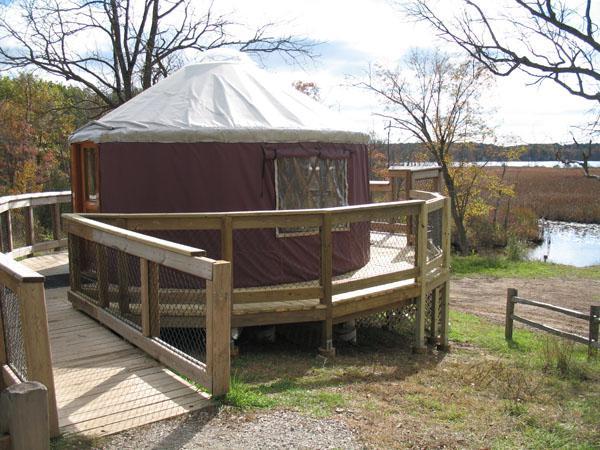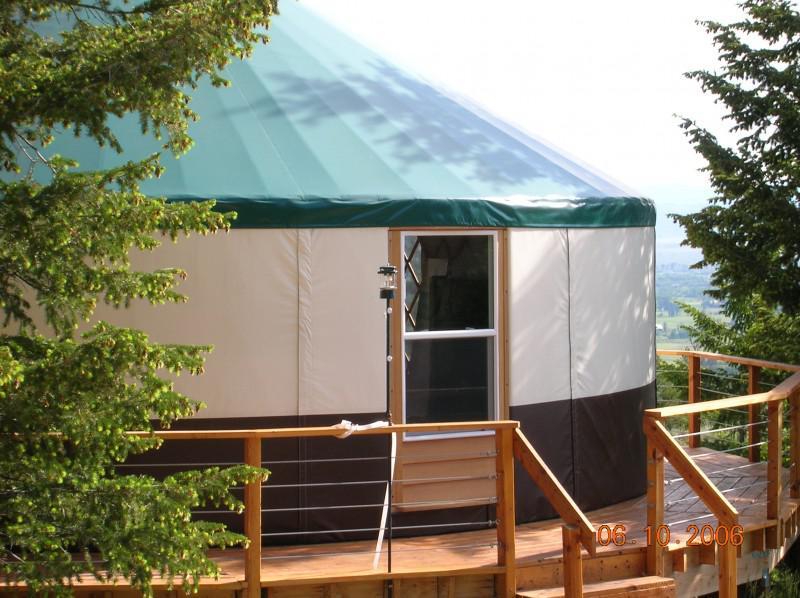The first image is the image on the left, the second image is the image on the right. Considering the images on both sides, is "Each image shows the front door of a single-story yurt with a roof that contrasts the walls, and a wooden decking entrance with railings." valid? Answer yes or no. Yes. The first image is the image on the left, the second image is the image on the right. Examine the images to the left and right. Is the description "Each image shows the exterior of one yurt, featuring some type of wood deck and railing." accurate? Answer yes or no. Yes. 